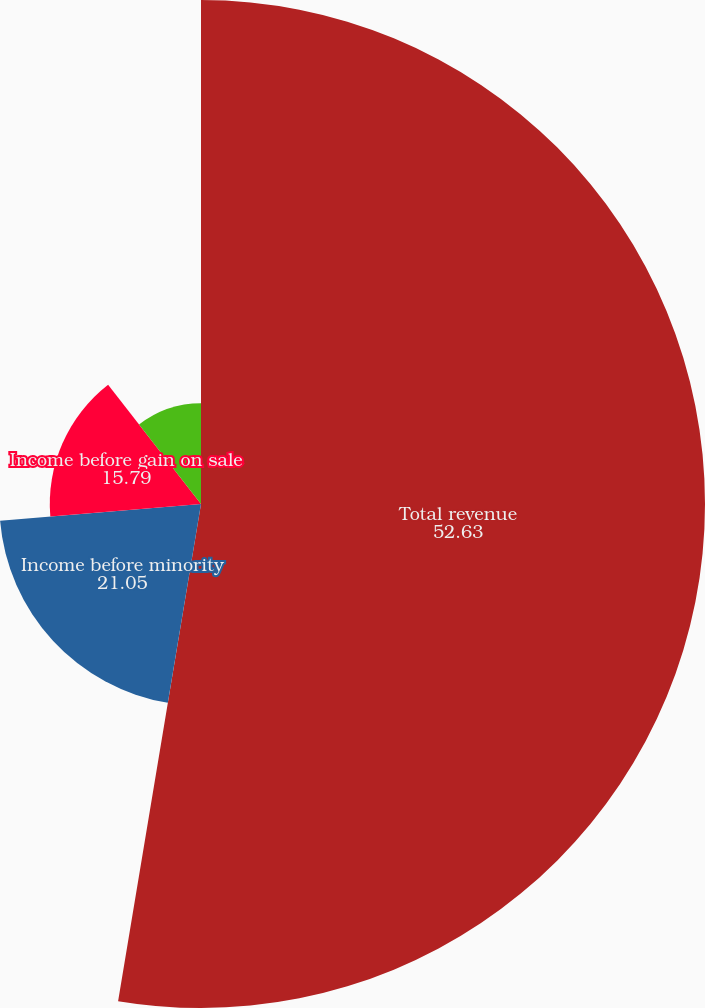Convert chart. <chart><loc_0><loc_0><loc_500><loc_500><pie_chart><fcel>Total revenue<fcel>Income before minority<fcel>Income before gain on sale<fcel>Net income available to common<fcel>Income before gain on sale per<nl><fcel>52.63%<fcel>21.05%<fcel>15.79%<fcel>10.53%<fcel>0.0%<nl></chart> 